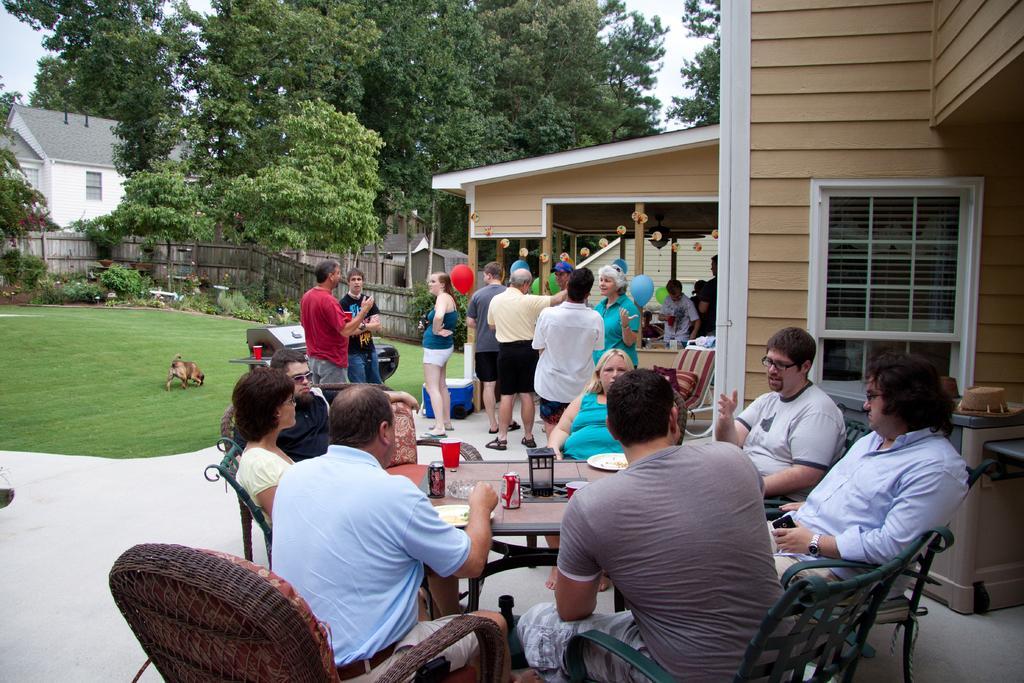How would you summarize this image in a sentence or two? There are some people sitting in the chairs around a table on which a tens, plates are placed. There were men and women in this group. Some of them was standing in the background. There is a garden in which a dog is there. There are some trees, houses and a sky in the background. 